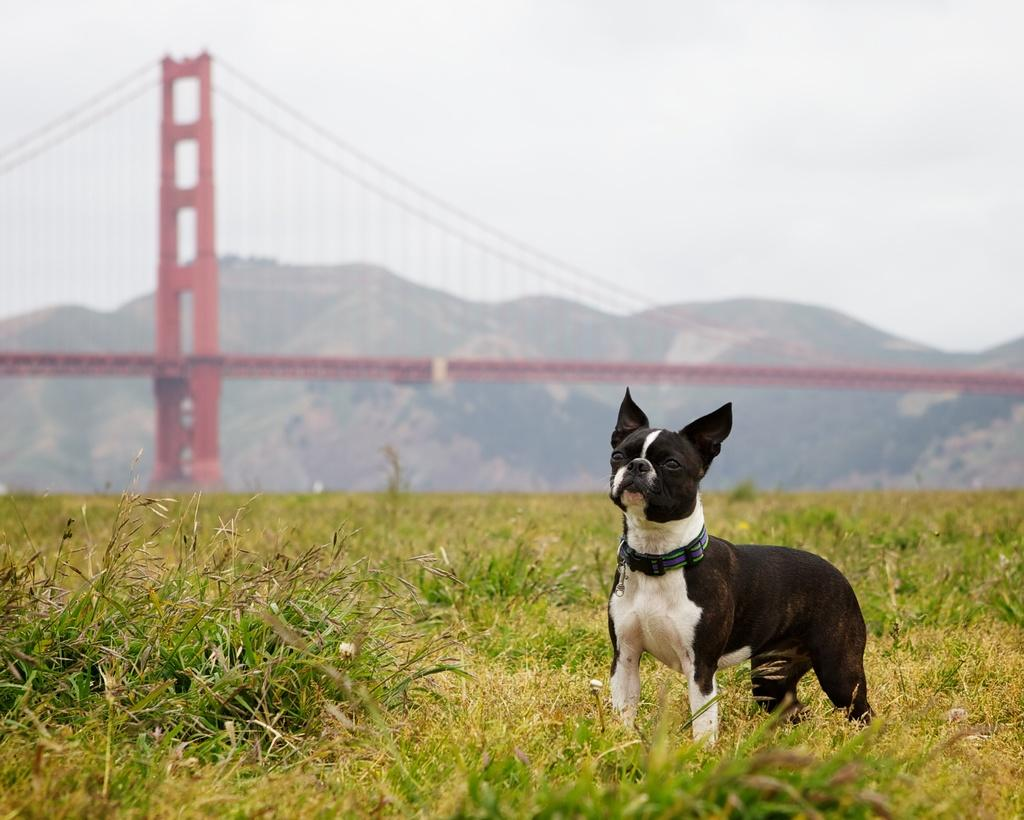What animal can be seen in the image? There is a dog in the image. What is the dog standing on? The dog is standing in between grass. What structure is visible behind the dog? There is a bridge behind the dog. What natural feature can be seen behind the bridge? There are mountains behind the bridge. What advice does the dog give to the planes in the image? There are no planes present in the image, so the dog cannot give any advice to them. 